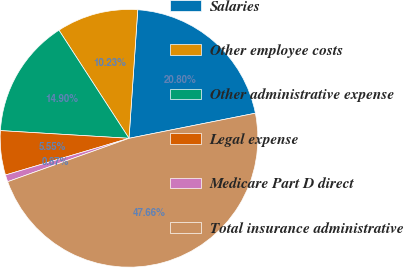<chart> <loc_0><loc_0><loc_500><loc_500><pie_chart><fcel>Salaries<fcel>Other employee costs<fcel>Other administrative expense<fcel>Legal expense<fcel>Medicare Part D direct<fcel>Total insurance administrative<nl><fcel>20.8%<fcel>10.23%<fcel>14.9%<fcel>5.55%<fcel>0.87%<fcel>47.66%<nl></chart> 